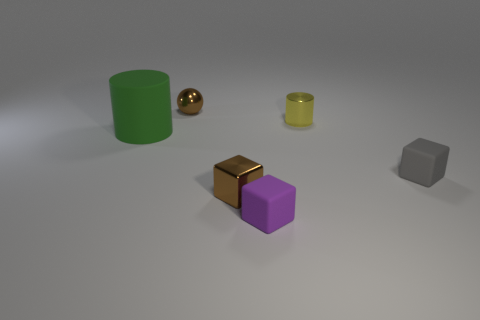Add 3 big cyan rubber things. How many objects exist? 9 Subtract all spheres. How many objects are left? 5 Subtract 0 purple spheres. How many objects are left? 6 Subtract all tiny matte objects. Subtract all yellow metal cylinders. How many objects are left? 3 Add 6 tiny brown metallic spheres. How many tiny brown metallic spheres are left? 7 Add 6 red metal objects. How many red metal objects exist? 6 